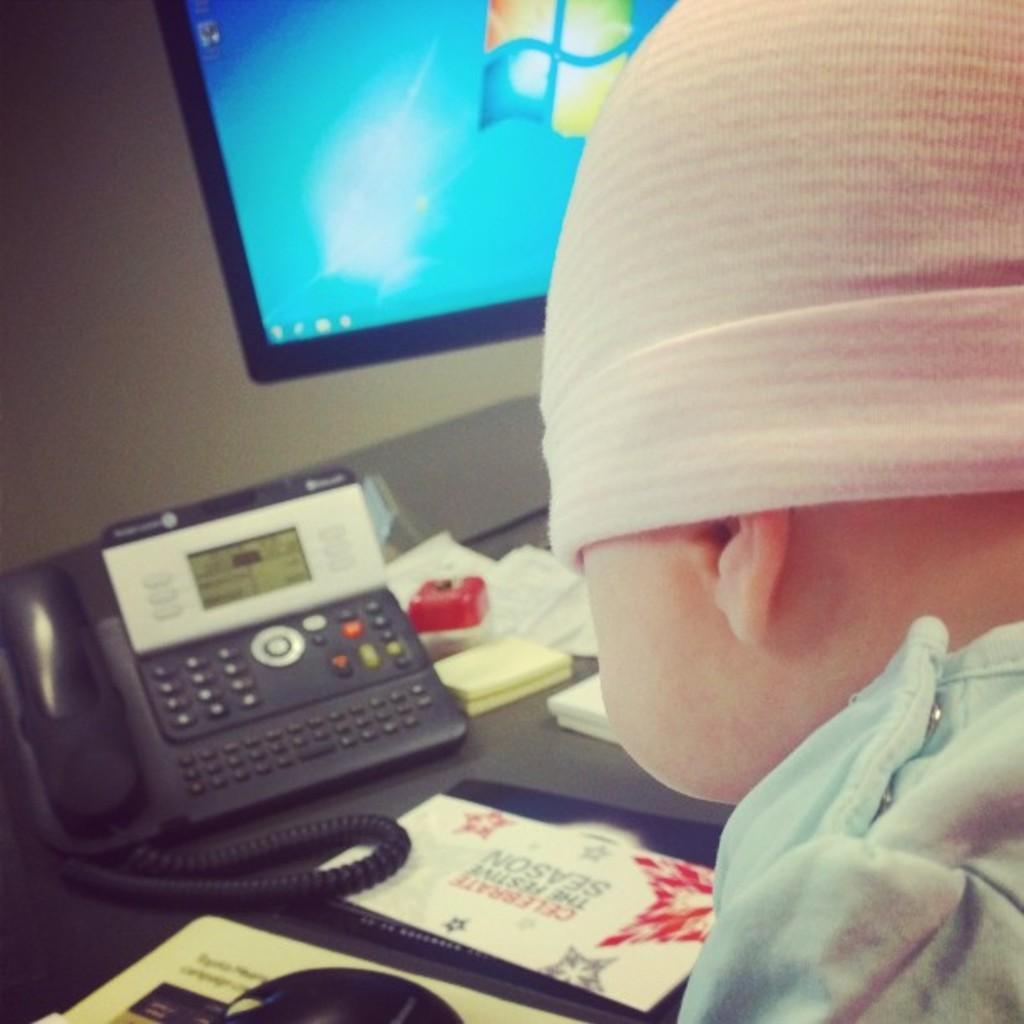Please provide a concise description of this image. In the image I can see a kid in front of the table on which there is a telephone, book and also I can see a screen to the side. 